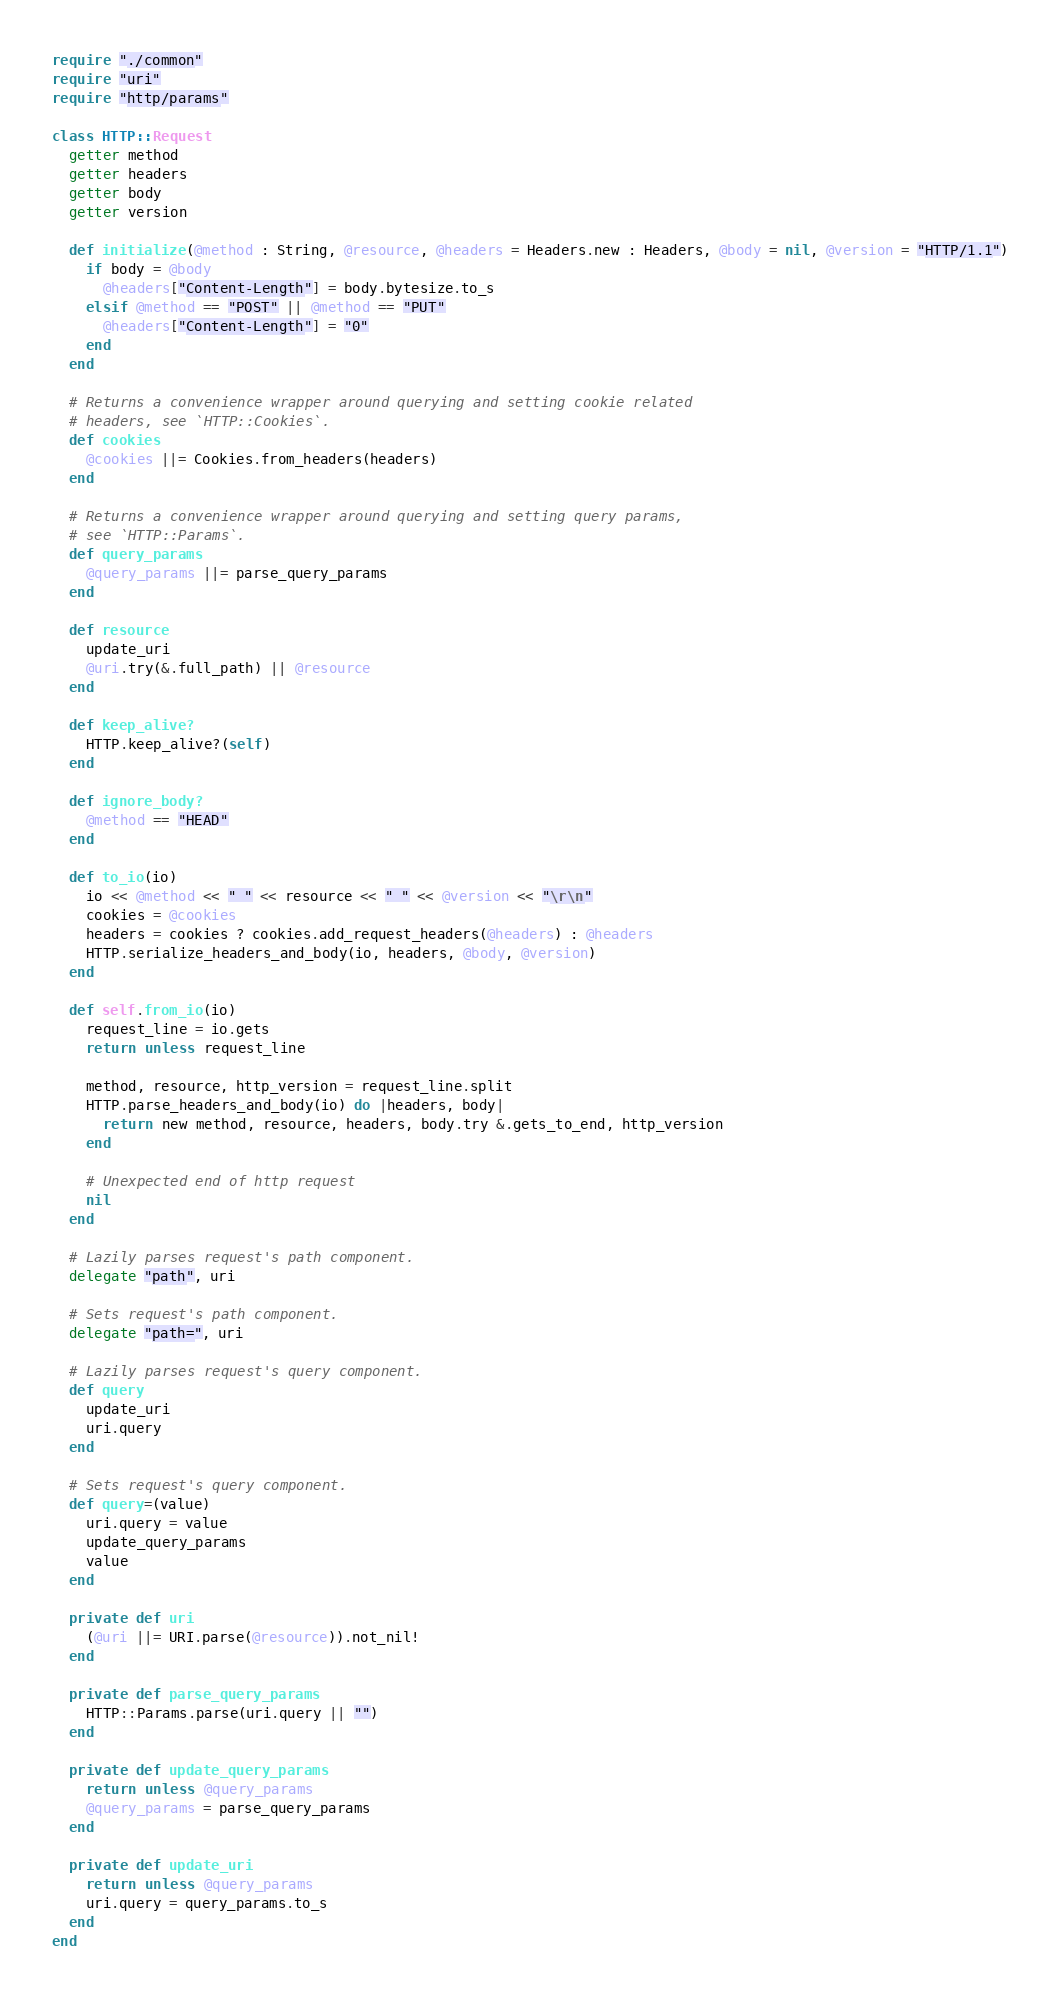Convert code to text. <code><loc_0><loc_0><loc_500><loc_500><_Crystal_>require "./common"
require "uri"
require "http/params"

class HTTP::Request
  getter method
  getter headers
  getter body
  getter version

  def initialize(@method : String, @resource, @headers = Headers.new : Headers, @body = nil, @version = "HTTP/1.1")
    if body = @body
      @headers["Content-Length"] = body.bytesize.to_s
    elsif @method == "POST" || @method == "PUT"
      @headers["Content-Length"] = "0"
    end
  end

  # Returns a convenience wrapper around querying and setting cookie related
  # headers, see `HTTP::Cookies`.
  def cookies
    @cookies ||= Cookies.from_headers(headers)
  end

  # Returns a convenience wrapper around querying and setting query params,
  # see `HTTP::Params`.
  def query_params
    @query_params ||= parse_query_params
  end

  def resource
    update_uri
    @uri.try(&.full_path) || @resource
  end

  def keep_alive?
    HTTP.keep_alive?(self)
  end

  def ignore_body?
    @method == "HEAD"
  end

  def to_io(io)
    io << @method << " " << resource << " " << @version << "\r\n"
    cookies = @cookies
    headers = cookies ? cookies.add_request_headers(@headers) : @headers
    HTTP.serialize_headers_and_body(io, headers, @body, @version)
  end

  def self.from_io(io)
    request_line = io.gets
    return unless request_line

    method, resource, http_version = request_line.split
    HTTP.parse_headers_and_body(io) do |headers, body|
      return new method, resource, headers, body.try &.gets_to_end, http_version
    end

    # Unexpected end of http request
    nil
  end

  # Lazily parses request's path component.
  delegate "path", uri

  # Sets request's path component.
  delegate "path=", uri

  # Lazily parses request's query component.
  def query
    update_uri
    uri.query
  end

  # Sets request's query component.
  def query=(value)
    uri.query = value
    update_query_params
    value
  end

  private def uri
    (@uri ||= URI.parse(@resource)).not_nil!
  end

  private def parse_query_params
    HTTP::Params.parse(uri.query || "")
  end

  private def update_query_params
    return unless @query_params
    @query_params = parse_query_params
  end

  private def update_uri
    return unless @query_params
    uri.query = query_params.to_s
  end
end
</code> 